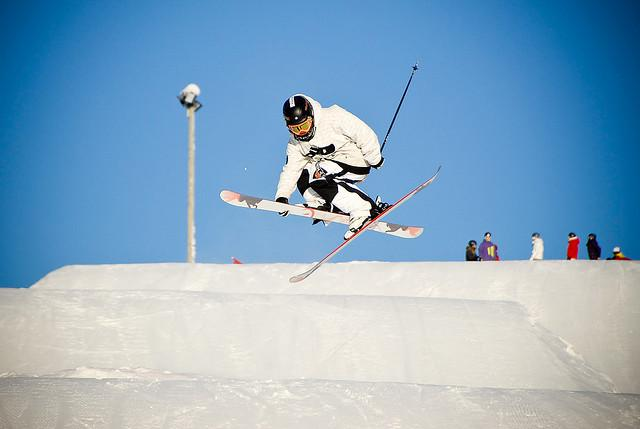Why is the man holding onto the ski? Please explain your reasoning. performing trick. A man on skis is in the air. 